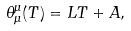Convert formula to latex. <formula><loc_0><loc_0><loc_500><loc_500>\theta ^ { \mu } _ { \mu } ( T ) = L T + A ,</formula> 